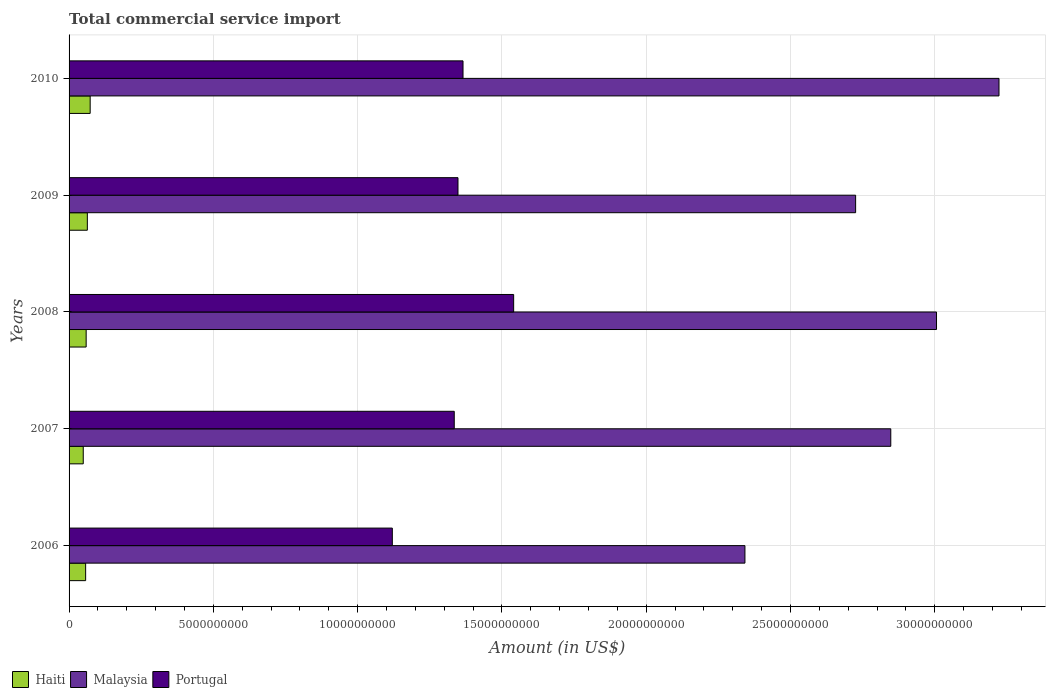How many groups of bars are there?
Offer a very short reply. 5. Are the number of bars on each tick of the Y-axis equal?
Your answer should be very brief. Yes. How many bars are there on the 3rd tick from the bottom?
Keep it short and to the point. 3. What is the label of the 3rd group of bars from the top?
Ensure brevity in your answer.  2008. What is the total commercial service import in Malaysia in 2009?
Your answer should be compact. 2.73e+1. Across all years, what is the maximum total commercial service import in Malaysia?
Provide a short and direct response. 3.22e+1. Across all years, what is the minimum total commercial service import in Portugal?
Give a very brief answer. 1.12e+1. In which year was the total commercial service import in Malaysia maximum?
Give a very brief answer. 2010. What is the total total commercial service import in Portugal in the graph?
Your answer should be very brief. 6.71e+1. What is the difference between the total commercial service import in Malaysia in 2007 and that in 2010?
Ensure brevity in your answer.  -3.75e+09. What is the difference between the total commercial service import in Portugal in 2006 and the total commercial service import in Malaysia in 2007?
Keep it short and to the point. -1.73e+1. What is the average total commercial service import in Portugal per year?
Your response must be concise. 1.34e+1. In the year 2010, what is the difference between the total commercial service import in Portugal and total commercial service import in Haiti?
Your answer should be compact. 1.29e+1. What is the ratio of the total commercial service import in Malaysia in 2006 to that in 2007?
Make the answer very short. 0.82. What is the difference between the highest and the second highest total commercial service import in Haiti?
Your answer should be compact. 9.79e+07. What is the difference between the highest and the lowest total commercial service import in Haiti?
Your answer should be compact. 2.40e+08. What does the 2nd bar from the top in 2008 represents?
Provide a short and direct response. Malaysia. Is it the case that in every year, the sum of the total commercial service import in Malaysia and total commercial service import in Portugal is greater than the total commercial service import in Haiti?
Ensure brevity in your answer.  Yes. How many years are there in the graph?
Your answer should be compact. 5. Where does the legend appear in the graph?
Provide a succinct answer. Bottom left. What is the title of the graph?
Provide a succinct answer. Total commercial service import. What is the Amount (in US$) of Haiti in 2006?
Your answer should be compact. 5.74e+08. What is the Amount (in US$) of Malaysia in 2006?
Your response must be concise. 2.34e+1. What is the Amount (in US$) in Portugal in 2006?
Keep it short and to the point. 1.12e+1. What is the Amount (in US$) in Haiti in 2007?
Offer a terse response. 4.91e+08. What is the Amount (in US$) in Malaysia in 2007?
Your answer should be very brief. 2.85e+1. What is the Amount (in US$) of Portugal in 2007?
Make the answer very short. 1.33e+1. What is the Amount (in US$) of Haiti in 2008?
Offer a very short reply. 5.92e+08. What is the Amount (in US$) of Malaysia in 2008?
Give a very brief answer. 3.01e+1. What is the Amount (in US$) in Portugal in 2008?
Offer a very short reply. 1.54e+1. What is the Amount (in US$) of Haiti in 2009?
Keep it short and to the point. 6.33e+08. What is the Amount (in US$) of Malaysia in 2009?
Give a very brief answer. 2.73e+1. What is the Amount (in US$) in Portugal in 2009?
Make the answer very short. 1.35e+1. What is the Amount (in US$) of Haiti in 2010?
Ensure brevity in your answer.  7.31e+08. What is the Amount (in US$) of Malaysia in 2010?
Provide a short and direct response. 3.22e+1. What is the Amount (in US$) of Portugal in 2010?
Provide a succinct answer. 1.37e+1. Across all years, what is the maximum Amount (in US$) in Haiti?
Your answer should be very brief. 7.31e+08. Across all years, what is the maximum Amount (in US$) in Malaysia?
Give a very brief answer. 3.22e+1. Across all years, what is the maximum Amount (in US$) in Portugal?
Your response must be concise. 1.54e+1. Across all years, what is the minimum Amount (in US$) of Haiti?
Your answer should be compact. 4.91e+08. Across all years, what is the minimum Amount (in US$) of Malaysia?
Your answer should be compact. 2.34e+1. Across all years, what is the minimum Amount (in US$) of Portugal?
Keep it short and to the point. 1.12e+1. What is the total Amount (in US$) in Haiti in the graph?
Offer a very short reply. 3.02e+09. What is the total Amount (in US$) in Malaysia in the graph?
Make the answer very short. 1.41e+11. What is the total Amount (in US$) in Portugal in the graph?
Make the answer very short. 6.71e+1. What is the difference between the Amount (in US$) of Haiti in 2006 and that in 2007?
Provide a succinct answer. 8.30e+07. What is the difference between the Amount (in US$) of Malaysia in 2006 and that in 2007?
Keep it short and to the point. -5.05e+09. What is the difference between the Amount (in US$) of Portugal in 2006 and that in 2007?
Your answer should be very brief. -2.15e+09. What is the difference between the Amount (in US$) of Haiti in 2006 and that in 2008?
Provide a succinct answer. -1.79e+07. What is the difference between the Amount (in US$) of Malaysia in 2006 and that in 2008?
Offer a very short reply. -6.64e+09. What is the difference between the Amount (in US$) in Portugal in 2006 and that in 2008?
Provide a succinct answer. -4.20e+09. What is the difference between the Amount (in US$) in Haiti in 2006 and that in 2009?
Your answer should be very brief. -5.90e+07. What is the difference between the Amount (in US$) of Malaysia in 2006 and that in 2009?
Give a very brief answer. -3.84e+09. What is the difference between the Amount (in US$) of Portugal in 2006 and that in 2009?
Offer a very short reply. -2.28e+09. What is the difference between the Amount (in US$) of Haiti in 2006 and that in 2010?
Your response must be concise. -1.57e+08. What is the difference between the Amount (in US$) in Malaysia in 2006 and that in 2010?
Keep it short and to the point. -8.80e+09. What is the difference between the Amount (in US$) in Portugal in 2006 and that in 2010?
Your answer should be very brief. -2.45e+09. What is the difference between the Amount (in US$) in Haiti in 2007 and that in 2008?
Make the answer very short. -1.01e+08. What is the difference between the Amount (in US$) in Malaysia in 2007 and that in 2008?
Keep it short and to the point. -1.58e+09. What is the difference between the Amount (in US$) of Portugal in 2007 and that in 2008?
Your answer should be very brief. -2.06e+09. What is the difference between the Amount (in US$) in Haiti in 2007 and that in 2009?
Provide a short and direct response. -1.42e+08. What is the difference between the Amount (in US$) of Malaysia in 2007 and that in 2009?
Ensure brevity in your answer.  1.22e+09. What is the difference between the Amount (in US$) in Portugal in 2007 and that in 2009?
Provide a succinct answer. -1.29e+08. What is the difference between the Amount (in US$) of Haiti in 2007 and that in 2010?
Your answer should be very brief. -2.40e+08. What is the difference between the Amount (in US$) in Malaysia in 2007 and that in 2010?
Ensure brevity in your answer.  -3.75e+09. What is the difference between the Amount (in US$) of Portugal in 2007 and that in 2010?
Give a very brief answer. -3.04e+08. What is the difference between the Amount (in US$) of Haiti in 2008 and that in 2009?
Your response must be concise. -4.11e+07. What is the difference between the Amount (in US$) in Malaysia in 2008 and that in 2009?
Keep it short and to the point. 2.80e+09. What is the difference between the Amount (in US$) of Portugal in 2008 and that in 2009?
Provide a short and direct response. 1.93e+09. What is the difference between the Amount (in US$) of Haiti in 2008 and that in 2010?
Provide a succinct answer. -1.39e+08. What is the difference between the Amount (in US$) of Malaysia in 2008 and that in 2010?
Give a very brief answer. -2.16e+09. What is the difference between the Amount (in US$) in Portugal in 2008 and that in 2010?
Your answer should be very brief. 1.75e+09. What is the difference between the Amount (in US$) of Haiti in 2009 and that in 2010?
Provide a succinct answer. -9.79e+07. What is the difference between the Amount (in US$) of Malaysia in 2009 and that in 2010?
Make the answer very short. -4.97e+09. What is the difference between the Amount (in US$) of Portugal in 2009 and that in 2010?
Provide a succinct answer. -1.75e+08. What is the difference between the Amount (in US$) of Haiti in 2006 and the Amount (in US$) of Malaysia in 2007?
Your answer should be compact. -2.79e+1. What is the difference between the Amount (in US$) of Haiti in 2006 and the Amount (in US$) of Portugal in 2007?
Provide a succinct answer. -1.28e+1. What is the difference between the Amount (in US$) of Malaysia in 2006 and the Amount (in US$) of Portugal in 2007?
Provide a succinct answer. 1.01e+1. What is the difference between the Amount (in US$) of Haiti in 2006 and the Amount (in US$) of Malaysia in 2008?
Offer a terse response. -2.95e+1. What is the difference between the Amount (in US$) of Haiti in 2006 and the Amount (in US$) of Portugal in 2008?
Give a very brief answer. -1.48e+1. What is the difference between the Amount (in US$) in Malaysia in 2006 and the Amount (in US$) in Portugal in 2008?
Provide a short and direct response. 8.02e+09. What is the difference between the Amount (in US$) in Haiti in 2006 and the Amount (in US$) in Malaysia in 2009?
Ensure brevity in your answer.  -2.67e+1. What is the difference between the Amount (in US$) of Haiti in 2006 and the Amount (in US$) of Portugal in 2009?
Offer a terse response. -1.29e+1. What is the difference between the Amount (in US$) of Malaysia in 2006 and the Amount (in US$) of Portugal in 2009?
Provide a succinct answer. 9.94e+09. What is the difference between the Amount (in US$) of Haiti in 2006 and the Amount (in US$) of Malaysia in 2010?
Ensure brevity in your answer.  -3.17e+1. What is the difference between the Amount (in US$) of Haiti in 2006 and the Amount (in US$) of Portugal in 2010?
Make the answer very short. -1.31e+1. What is the difference between the Amount (in US$) of Malaysia in 2006 and the Amount (in US$) of Portugal in 2010?
Offer a terse response. 9.77e+09. What is the difference between the Amount (in US$) in Haiti in 2007 and the Amount (in US$) in Malaysia in 2008?
Keep it short and to the point. -2.96e+1. What is the difference between the Amount (in US$) in Haiti in 2007 and the Amount (in US$) in Portugal in 2008?
Make the answer very short. -1.49e+1. What is the difference between the Amount (in US$) of Malaysia in 2007 and the Amount (in US$) of Portugal in 2008?
Make the answer very short. 1.31e+1. What is the difference between the Amount (in US$) in Haiti in 2007 and the Amount (in US$) in Malaysia in 2009?
Your answer should be compact. -2.68e+1. What is the difference between the Amount (in US$) in Haiti in 2007 and the Amount (in US$) in Portugal in 2009?
Provide a succinct answer. -1.30e+1. What is the difference between the Amount (in US$) of Malaysia in 2007 and the Amount (in US$) of Portugal in 2009?
Offer a very short reply. 1.50e+1. What is the difference between the Amount (in US$) of Haiti in 2007 and the Amount (in US$) of Malaysia in 2010?
Give a very brief answer. -3.17e+1. What is the difference between the Amount (in US$) of Haiti in 2007 and the Amount (in US$) of Portugal in 2010?
Make the answer very short. -1.32e+1. What is the difference between the Amount (in US$) of Malaysia in 2007 and the Amount (in US$) of Portugal in 2010?
Your answer should be very brief. 1.48e+1. What is the difference between the Amount (in US$) of Haiti in 2008 and the Amount (in US$) of Malaysia in 2009?
Offer a terse response. -2.67e+1. What is the difference between the Amount (in US$) in Haiti in 2008 and the Amount (in US$) in Portugal in 2009?
Your response must be concise. -1.29e+1. What is the difference between the Amount (in US$) of Malaysia in 2008 and the Amount (in US$) of Portugal in 2009?
Give a very brief answer. 1.66e+1. What is the difference between the Amount (in US$) in Haiti in 2008 and the Amount (in US$) in Malaysia in 2010?
Provide a succinct answer. -3.16e+1. What is the difference between the Amount (in US$) of Haiti in 2008 and the Amount (in US$) of Portugal in 2010?
Provide a short and direct response. -1.31e+1. What is the difference between the Amount (in US$) in Malaysia in 2008 and the Amount (in US$) in Portugal in 2010?
Provide a succinct answer. 1.64e+1. What is the difference between the Amount (in US$) in Haiti in 2009 and the Amount (in US$) in Malaysia in 2010?
Your answer should be compact. -3.16e+1. What is the difference between the Amount (in US$) of Haiti in 2009 and the Amount (in US$) of Portugal in 2010?
Your answer should be very brief. -1.30e+1. What is the difference between the Amount (in US$) of Malaysia in 2009 and the Amount (in US$) of Portugal in 2010?
Make the answer very short. 1.36e+1. What is the average Amount (in US$) in Haiti per year?
Give a very brief answer. 6.04e+08. What is the average Amount (in US$) of Malaysia per year?
Offer a very short reply. 2.83e+1. What is the average Amount (in US$) in Portugal per year?
Your answer should be very brief. 1.34e+1. In the year 2006, what is the difference between the Amount (in US$) of Haiti and Amount (in US$) of Malaysia?
Provide a succinct answer. -2.28e+1. In the year 2006, what is the difference between the Amount (in US$) of Haiti and Amount (in US$) of Portugal?
Offer a terse response. -1.06e+1. In the year 2006, what is the difference between the Amount (in US$) in Malaysia and Amount (in US$) in Portugal?
Give a very brief answer. 1.22e+1. In the year 2007, what is the difference between the Amount (in US$) of Haiti and Amount (in US$) of Malaysia?
Your response must be concise. -2.80e+1. In the year 2007, what is the difference between the Amount (in US$) of Haiti and Amount (in US$) of Portugal?
Give a very brief answer. -1.29e+1. In the year 2007, what is the difference between the Amount (in US$) in Malaysia and Amount (in US$) in Portugal?
Provide a succinct answer. 1.51e+1. In the year 2008, what is the difference between the Amount (in US$) in Haiti and Amount (in US$) in Malaysia?
Your response must be concise. -2.95e+1. In the year 2008, what is the difference between the Amount (in US$) in Haiti and Amount (in US$) in Portugal?
Provide a succinct answer. -1.48e+1. In the year 2008, what is the difference between the Amount (in US$) of Malaysia and Amount (in US$) of Portugal?
Provide a succinct answer. 1.47e+1. In the year 2009, what is the difference between the Amount (in US$) in Haiti and Amount (in US$) in Malaysia?
Ensure brevity in your answer.  -2.66e+1. In the year 2009, what is the difference between the Amount (in US$) in Haiti and Amount (in US$) in Portugal?
Provide a short and direct response. -1.28e+1. In the year 2009, what is the difference between the Amount (in US$) in Malaysia and Amount (in US$) in Portugal?
Offer a terse response. 1.38e+1. In the year 2010, what is the difference between the Amount (in US$) in Haiti and Amount (in US$) in Malaysia?
Your answer should be very brief. -3.15e+1. In the year 2010, what is the difference between the Amount (in US$) in Haiti and Amount (in US$) in Portugal?
Your answer should be compact. -1.29e+1. In the year 2010, what is the difference between the Amount (in US$) of Malaysia and Amount (in US$) of Portugal?
Provide a succinct answer. 1.86e+1. What is the ratio of the Amount (in US$) in Haiti in 2006 to that in 2007?
Your answer should be very brief. 1.17. What is the ratio of the Amount (in US$) in Malaysia in 2006 to that in 2007?
Offer a very short reply. 0.82. What is the ratio of the Amount (in US$) of Portugal in 2006 to that in 2007?
Make the answer very short. 0.84. What is the ratio of the Amount (in US$) in Haiti in 2006 to that in 2008?
Make the answer very short. 0.97. What is the ratio of the Amount (in US$) of Malaysia in 2006 to that in 2008?
Your response must be concise. 0.78. What is the ratio of the Amount (in US$) of Portugal in 2006 to that in 2008?
Your answer should be compact. 0.73. What is the ratio of the Amount (in US$) of Haiti in 2006 to that in 2009?
Your answer should be compact. 0.91. What is the ratio of the Amount (in US$) in Malaysia in 2006 to that in 2009?
Provide a succinct answer. 0.86. What is the ratio of the Amount (in US$) in Portugal in 2006 to that in 2009?
Offer a terse response. 0.83. What is the ratio of the Amount (in US$) of Haiti in 2006 to that in 2010?
Keep it short and to the point. 0.79. What is the ratio of the Amount (in US$) of Malaysia in 2006 to that in 2010?
Ensure brevity in your answer.  0.73. What is the ratio of the Amount (in US$) in Portugal in 2006 to that in 2010?
Ensure brevity in your answer.  0.82. What is the ratio of the Amount (in US$) in Haiti in 2007 to that in 2008?
Give a very brief answer. 0.83. What is the ratio of the Amount (in US$) in Malaysia in 2007 to that in 2008?
Keep it short and to the point. 0.95. What is the ratio of the Amount (in US$) in Portugal in 2007 to that in 2008?
Your response must be concise. 0.87. What is the ratio of the Amount (in US$) in Haiti in 2007 to that in 2009?
Provide a succinct answer. 0.78. What is the ratio of the Amount (in US$) in Malaysia in 2007 to that in 2009?
Provide a succinct answer. 1.04. What is the ratio of the Amount (in US$) of Haiti in 2007 to that in 2010?
Give a very brief answer. 0.67. What is the ratio of the Amount (in US$) of Malaysia in 2007 to that in 2010?
Provide a short and direct response. 0.88. What is the ratio of the Amount (in US$) of Portugal in 2007 to that in 2010?
Offer a very short reply. 0.98. What is the ratio of the Amount (in US$) in Haiti in 2008 to that in 2009?
Offer a terse response. 0.94. What is the ratio of the Amount (in US$) of Malaysia in 2008 to that in 2009?
Keep it short and to the point. 1.1. What is the ratio of the Amount (in US$) in Portugal in 2008 to that in 2009?
Keep it short and to the point. 1.14. What is the ratio of the Amount (in US$) in Haiti in 2008 to that in 2010?
Make the answer very short. 0.81. What is the ratio of the Amount (in US$) in Malaysia in 2008 to that in 2010?
Your response must be concise. 0.93. What is the ratio of the Amount (in US$) of Portugal in 2008 to that in 2010?
Provide a short and direct response. 1.13. What is the ratio of the Amount (in US$) of Haiti in 2009 to that in 2010?
Provide a succinct answer. 0.87. What is the ratio of the Amount (in US$) in Malaysia in 2009 to that in 2010?
Give a very brief answer. 0.85. What is the ratio of the Amount (in US$) of Portugal in 2009 to that in 2010?
Provide a succinct answer. 0.99. What is the difference between the highest and the second highest Amount (in US$) in Haiti?
Your answer should be very brief. 9.79e+07. What is the difference between the highest and the second highest Amount (in US$) in Malaysia?
Give a very brief answer. 2.16e+09. What is the difference between the highest and the second highest Amount (in US$) of Portugal?
Your answer should be very brief. 1.75e+09. What is the difference between the highest and the lowest Amount (in US$) in Haiti?
Your answer should be very brief. 2.40e+08. What is the difference between the highest and the lowest Amount (in US$) in Malaysia?
Provide a short and direct response. 8.80e+09. What is the difference between the highest and the lowest Amount (in US$) in Portugal?
Your response must be concise. 4.20e+09. 